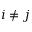<formula> <loc_0><loc_0><loc_500><loc_500>i \neq j</formula> 